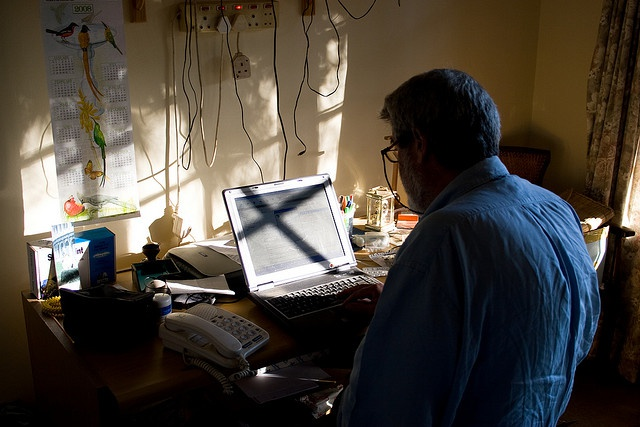Describe the objects in this image and their specific colors. I can see people in black, navy, and blue tones, laptop in black, lightgray, darkgray, and gray tones, keyboard in black, darkgray, lightgray, and gray tones, and cup in black, white, darkgray, and gray tones in this image. 